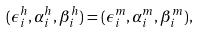<formula> <loc_0><loc_0><loc_500><loc_500>( \epsilon _ { i } ^ { h } , \alpha _ { i } ^ { h } , \beta _ { i } ^ { h } ) = ( \epsilon _ { i } ^ { m } , \alpha _ { i } ^ { m } , \beta _ { i } ^ { m } ) ,</formula> 